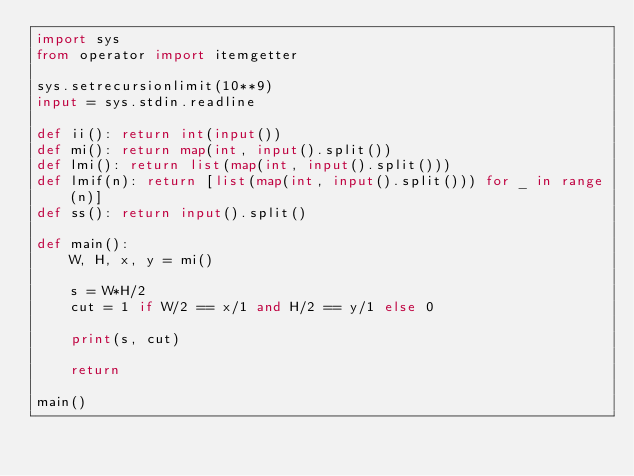<code> <loc_0><loc_0><loc_500><loc_500><_Python_>import sys
from operator import itemgetter

sys.setrecursionlimit(10**9)
input = sys.stdin.readline

def ii(): return int(input())
def mi(): return map(int, input().split())
def lmi(): return list(map(int, input().split()))
def lmif(n): return [list(map(int, input().split())) for _ in range(n)]
def ss(): return input().split()

def main():
    W, H, x, y = mi()

    s = W*H/2
    cut = 1 if W/2 == x/1 and H/2 == y/1 else 0

    print(s, cut)

    return

main()
</code> 